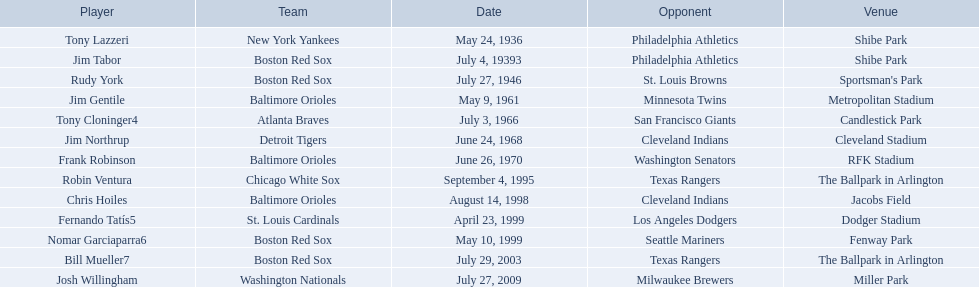What venue did detroit play cleveland in? Cleveland Stadium. Who was the player? Jim Northrup. What date did they play? June 24, 1968. What are the names of all the players? Tony Lazzeri, Jim Tabor, Rudy York, Jim Gentile, Tony Cloninger4, Jim Northrup, Frank Robinson, Robin Ventura, Chris Hoiles, Fernando Tatís5, Nomar Garciaparra6, Bill Mueller7, Josh Willingham. What are the names of all the teams holding home run records? New York Yankees, Boston Red Sox, Baltimore Orioles, Atlanta Braves, Detroit Tigers, Chicago White Sox, St. Louis Cardinals, Washington Nationals. Which player played for the new york yankees? Tony Lazzeri. 